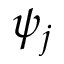Convert formula to latex. <formula><loc_0><loc_0><loc_500><loc_500>\psi _ { j }</formula> 